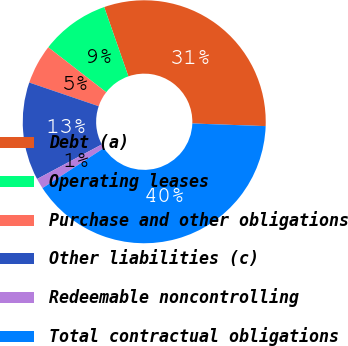Convert chart. <chart><loc_0><loc_0><loc_500><loc_500><pie_chart><fcel>Debt (a)<fcel>Operating leases<fcel>Purchase and other obligations<fcel>Other liabilities (c)<fcel>Redeemable noncontrolling<fcel>Total contractual obligations<nl><fcel>30.92%<fcel>9.15%<fcel>5.27%<fcel>13.04%<fcel>1.39%<fcel>40.23%<nl></chart> 